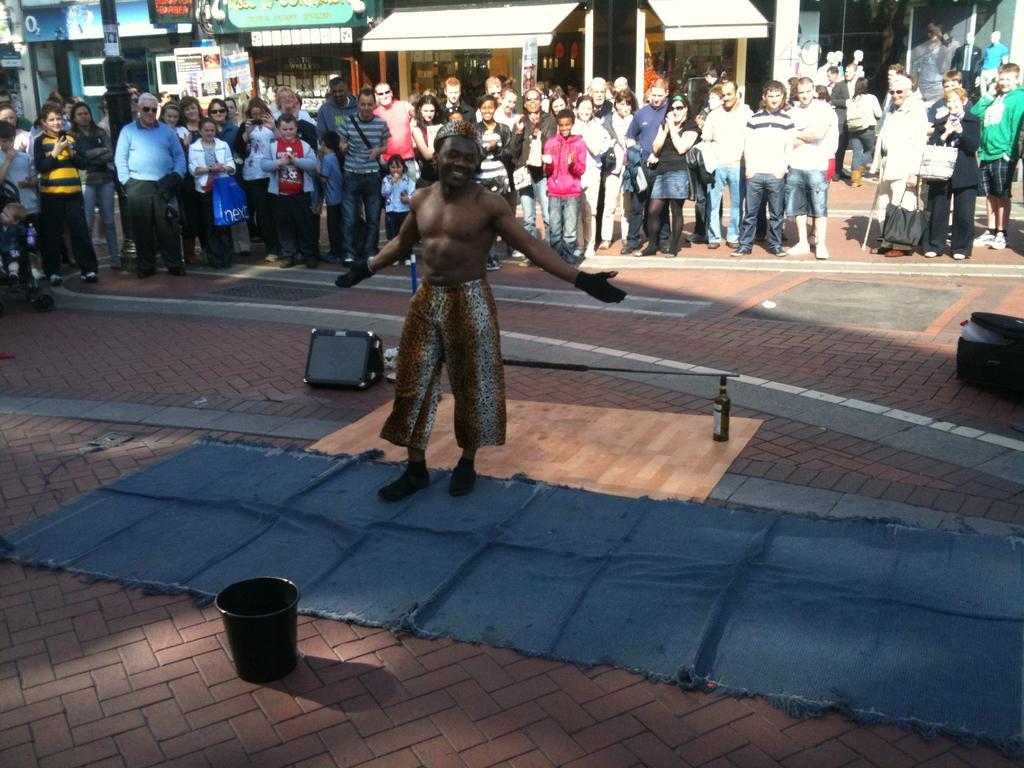Please provide a concise description of this image. This picture is taken on a street. In the center, there is a man wearing a brown short. At the bottom, there is a bucket and a blue mat. On the top, there are people staring at him. Behind them there are buildings with stores. Towards the right, there is a bag. 